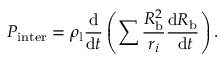<formula> <loc_0><loc_0><loc_500><loc_500>P _ { i n t e r } = \rho _ { l } \frac { d } { d t } \left ( \sum \frac { R _ { b } ^ { 2 } } { r _ { i } } \frac { d R _ { b } } { d t } \right ) .</formula> 